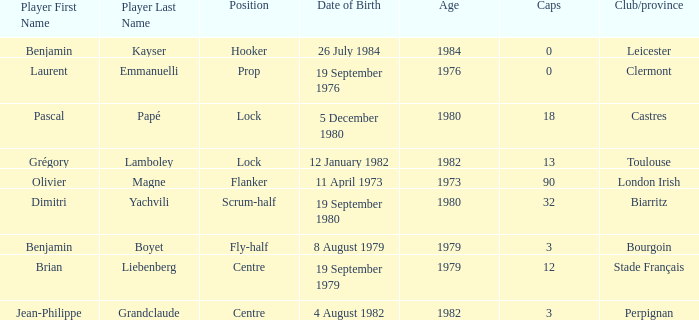Which individual has a cap count exceeding 12 and belongs to clubs of toulouse? Grégory Lamboley. 